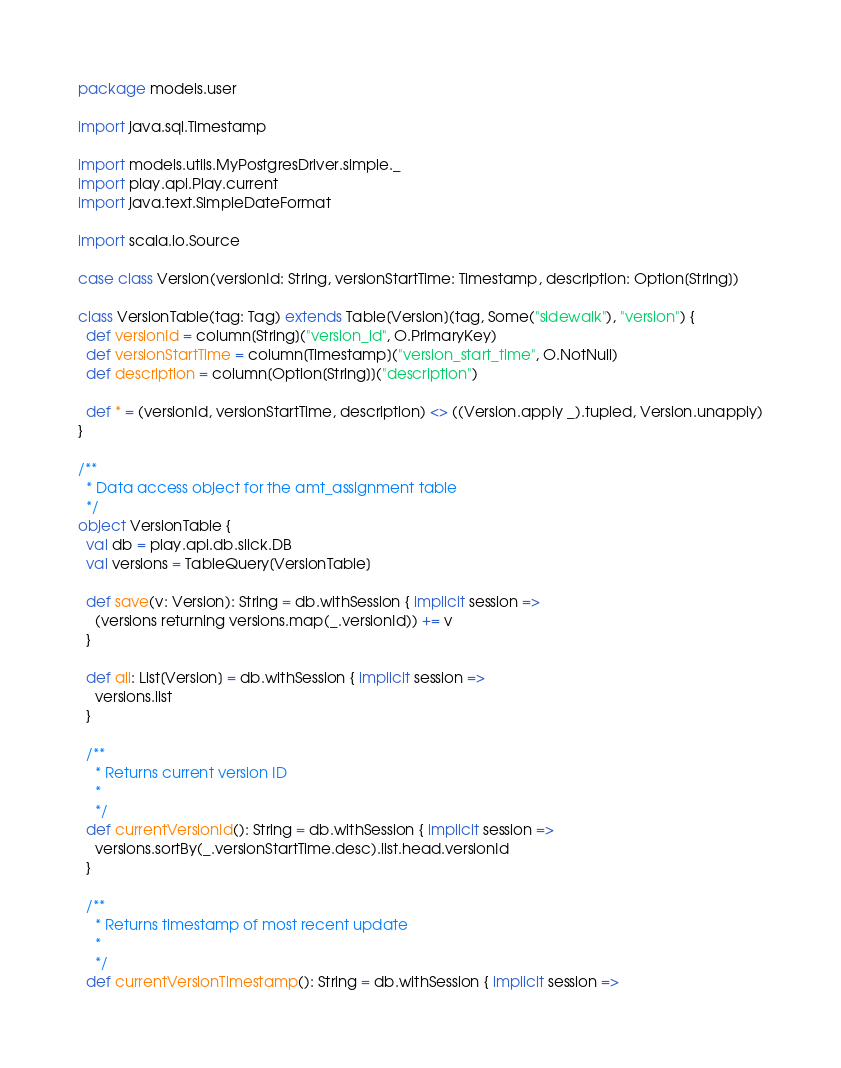<code> <loc_0><loc_0><loc_500><loc_500><_Scala_>package models.user

import java.sql.Timestamp

import models.utils.MyPostgresDriver.simple._
import play.api.Play.current
import java.text.SimpleDateFormat

import scala.io.Source

case class Version(versionId: String, versionStartTime: Timestamp, description: Option[String])

class VersionTable(tag: Tag) extends Table[Version](tag, Some("sidewalk"), "version") {
  def versionId = column[String]("version_id", O.PrimaryKey)
  def versionStartTime = column[Timestamp]("version_start_time", O.NotNull)
  def description = column[Option[String]]("description")

  def * = (versionId, versionStartTime, description) <> ((Version.apply _).tupled, Version.unapply)
}

/**
  * Data access object for the amt_assignment table
  */
object VersionTable {
  val db = play.api.db.slick.DB
  val versions = TableQuery[VersionTable]

  def save(v: Version): String = db.withSession { implicit session =>
    (versions returning versions.map(_.versionId)) += v
  }

  def all: List[Version] = db.withSession { implicit session =>
    versions.list
  }

  /**
    * Returns current version ID
    *
    */
  def currentVersionId(): String = db.withSession { implicit session =>
    versions.sortBy(_.versionStartTime.desc).list.head.versionId
  }

  /**
    * Returns timestamp of most recent update
    *
    */
  def currentVersionTimestamp(): String = db.withSession { implicit session =></code> 